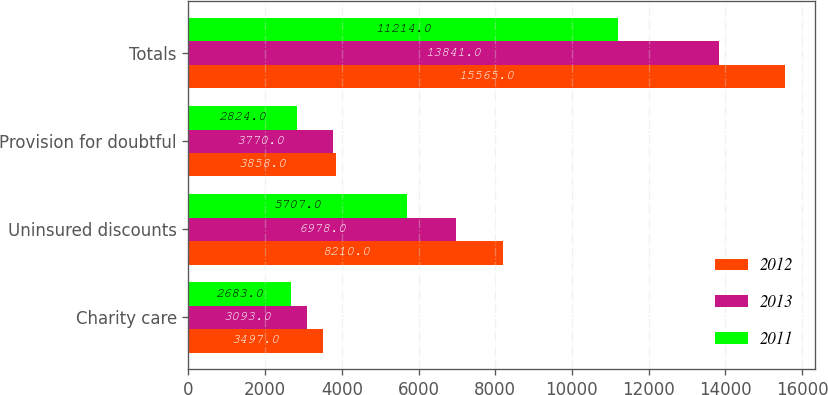Convert chart. <chart><loc_0><loc_0><loc_500><loc_500><stacked_bar_chart><ecel><fcel>Charity care<fcel>Uninsured discounts<fcel>Provision for doubtful<fcel>Totals<nl><fcel>2012<fcel>3497<fcel>8210<fcel>3858<fcel>15565<nl><fcel>2013<fcel>3093<fcel>6978<fcel>3770<fcel>13841<nl><fcel>2011<fcel>2683<fcel>5707<fcel>2824<fcel>11214<nl></chart> 